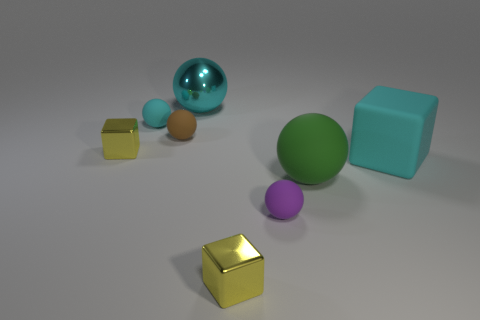Subtract all green spheres. How many spheres are left? 4 Subtract all green rubber spheres. How many spheres are left? 4 Subtract all blue balls. Subtract all red cubes. How many balls are left? 5 Add 1 metal cubes. How many objects exist? 9 Subtract all cubes. How many objects are left? 5 Subtract 0 gray balls. How many objects are left? 8 Subtract all small green balls. Subtract all tiny cyan things. How many objects are left? 7 Add 5 cyan spheres. How many cyan spheres are left? 7 Add 7 tiny brown rubber spheres. How many tiny brown rubber spheres exist? 8 